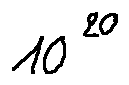<formula> <loc_0><loc_0><loc_500><loc_500>1 0 ^ { 2 0 }</formula> 